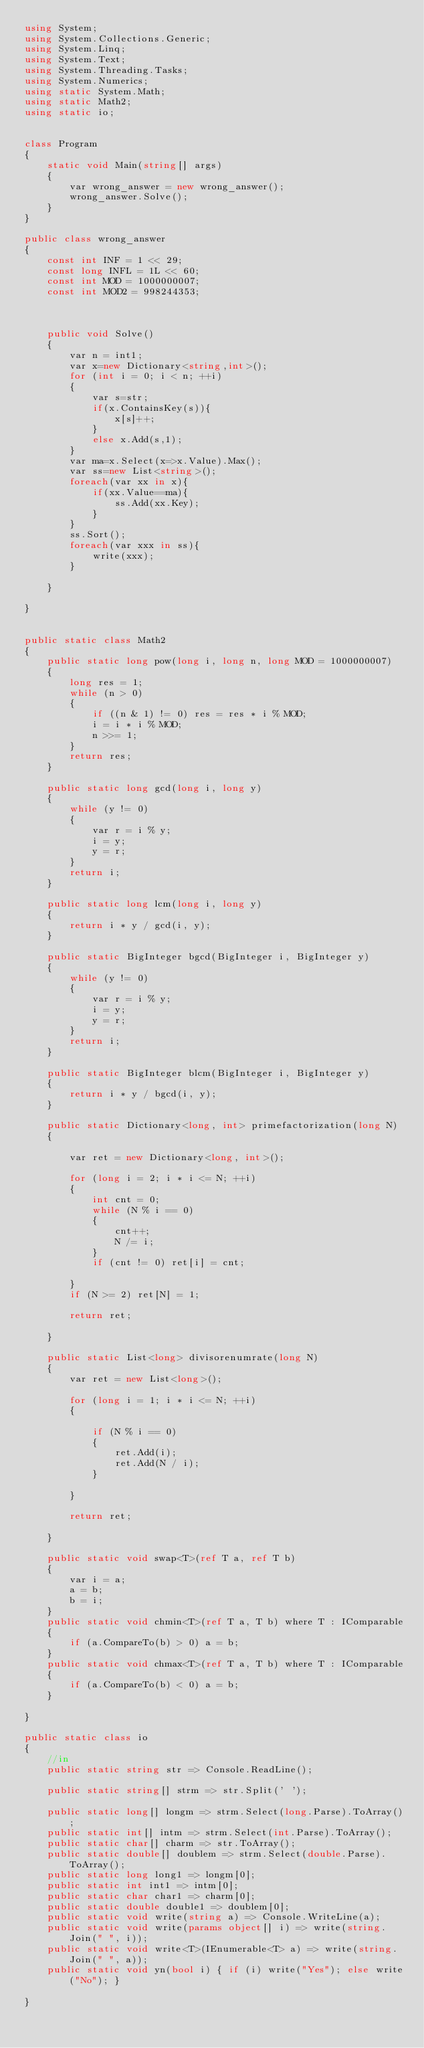Convert code to text. <code><loc_0><loc_0><loc_500><loc_500><_C#_>using System;
using System.Collections.Generic;
using System.Linq;
using System.Text;
using System.Threading.Tasks;
using System.Numerics;
using static System.Math;
using static Math2;
using static io;


class Program
{
    static void Main(string[] args)
    {
        var wrong_answer = new wrong_answer();
        wrong_answer.Solve();
    }
}

public class wrong_answer
{
    const int INF = 1 << 29;
    const long INFL = 1L << 60;
    const int MOD = 1000000007;
    const int MOD2 = 998244353;



    public void Solve()
    {
        var n = int1;
        var x=new Dictionary<string,int>();
        for (int i = 0; i < n; ++i)
        {
            var s=str;
            if(x.ContainsKey(s)){
                x[s]++;
            }
            else x.Add(s,1);
        }
        var ma=x.Select(x=>x.Value).Max();
        var ss=new List<string>();
        foreach(var xx in x){
            if(xx.Value==ma){
                ss.Add(xx.Key);
            }
        }
        ss.Sort();
        foreach(var xxx in ss){
            write(xxx);
        }
    
    }

}


public static class Math2
{
    public static long pow(long i, long n, long MOD = 1000000007)
    {
        long res = 1;
        while (n > 0)
        {
            if ((n & 1) != 0) res = res * i % MOD;
            i = i * i % MOD;
            n >>= 1;
        }
        return res;
    }

    public static long gcd(long i, long y)
    {
        while (y != 0)
        {
            var r = i % y;
            i = y;
            y = r;
        }
        return i;
    }

    public static long lcm(long i, long y)
    {
        return i * y / gcd(i, y);
    }

    public static BigInteger bgcd(BigInteger i, BigInteger y)
    {
        while (y != 0)
        {
            var r = i % y;
            i = y;
            y = r;
        }
        return i;
    }

    public static BigInteger blcm(BigInteger i, BigInteger y)
    {
        return i * y / bgcd(i, y);
    }

    public static Dictionary<long, int> primefactorization(long N)
    {

        var ret = new Dictionary<long, int>();

        for (long i = 2; i * i <= N; ++i)
        {
            int cnt = 0;
            while (N % i == 0)
            {
                cnt++;
                N /= i;
            }
            if (cnt != 0) ret[i] = cnt;

        }
        if (N >= 2) ret[N] = 1;

        return ret;

    }

    public static List<long> divisorenumrate(long N)
    {
        var ret = new List<long>();

        for (long i = 1; i * i <= N; ++i)
        {

            if (N % i == 0)
            {
                ret.Add(i);
                ret.Add(N / i);
            }

        }

        return ret;

    }

    public static void swap<T>(ref T a, ref T b)
    {
        var i = a;
        a = b;
        b = i;
    }
    public static void chmin<T>(ref T a, T b) where T : IComparable
    {
        if (a.CompareTo(b) > 0) a = b;
    }
    public static void chmax<T>(ref T a, T b) where T : IComparable
    {
        if (a.CompareTo(b) < 0) a = b;
    }

}

public static class io
{
    //in
    public static string str => Console.ReadLine();

    public static string[] strm => str.Split(' ');

    public static long[] longm => strm.Select(long.Parse).ToArray();
    public static int[] intm => strm.Select(int.Parse).ToArray();
    public static char[] charm => str.ToArray();
    public static double[] doublem => strm.Select(double.Parse).ToArray();
    public static long long1 => longm[0];
    public static int int1 => intm[0];
    public static char char1 => charm[0];
    public static double double1 => doublem[0];
    public static void write(string a) => Console.WriteLine(a);
    public static void write(params object[] i) => write(string.Join(" ", i));
    public static void write<T>(IEnumerable<T> a) => write(string.Join(" ", a));
    public static void yn(bool i) { if (i) write("Yes"); else write("No"); }

}
</code> 